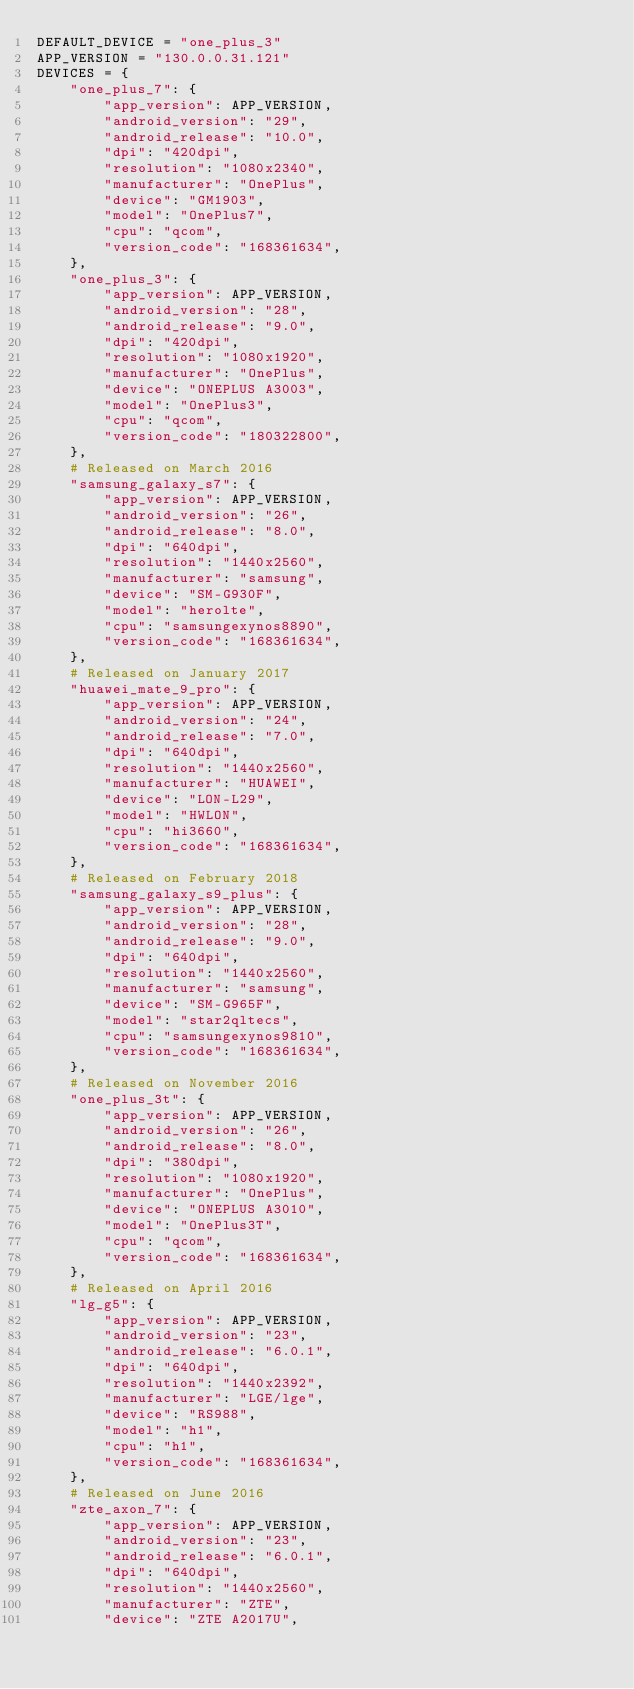Convert code to text. <code><loc_0><loc_0><loc_500><loc_500><_Python_>DEFAULT_DEVICE = "one_plus_3"
APP_VERSION = "130.0.0.31.121"
DEVICES = {
    "one_plus_7": {
        "app_version": APP_VERSION,
        "android_version": "29",
        "android_release": "10.0",
        "dpi": "420dpi",
        "resolution": "1080x2340",
        "manufacturer": "OnePlus",
        "device": "GM1903",
        "model": "OnePlus7",
        "cpu": "qcom",
        "version_code": "168361634",
    },
    "one_plus_3": {
        "app_version": APP_VERSION,
        "android_version": "28",
        "android_release": "9.0",
        "dpi": "420dpi",
        "resolution": "1080x1920",
        "manufacturer": "OnePlus",
        "device": "ONEPLUS A3003",
        "model": "OnePlus3",
        "cpu": "qcom",
        "version_code": "180322800",
    },
    # Released on March 2016
    "samsung_galaxy_s7": {
        "app_version": APP_VERSION,
        "android_version": "26",
        "android_release": "8.0",
        "dpi": "640dpi",
        "resolution": "1440x2560",
        "manufacturer": "samsung",
        "device": "SM-G930F",
        "model": "herolte",
        "cpu": "samsungexynos8890",
        "version_code": "168361634",
    },
    # Released on January 2017
    "huawei_mate_9_pro": {
        "app_version": APP_VERSION,
        "android_version": "24",
        "android_release": "7.0",
        "dpi": "640dpi",
        "resolution": "1440x2560",
        "manufacturer": "HUAWEI",
        "device": "LON-L29",
        "model": "HWLON",
        "cpu": "hi3660",
        "version_code": "168361634",
    },
    # Released on February 2018
    "samsung_galaxy_s9_plus": {
        "app_version": APP_VERSION,
        "android_version": "28",
        "android_release": "9.0",
        "dpi": "640dpi",
        "resolution": "1440x2560",
        "manufacturer": "samsung",
        "device": "SM-G965F",
        "model": "star2qltecs",
        "cpu": "samsungexynos9810",
        "version_code": "168361634",
    },
    # Released on November 2016
    "one_plus_3t": {
        "app_version": APP_VERSION,
        "android_version": "26",
        "android_release": "8.0",
        "dpi": "380dpi",
        "resolution": "1080x1920",
        "manufacturer": "OnePlus",
        "device": "ONEPLUS A3010",
        "model": "OnePlus3T",
        "cpu": "qcom",
        "version_code": "168361634",
    },
    # Released on April 2016
    "lg_g5": {
        "app_version": APP_VERSION,
        "android_version": "23",
        "android_release": "6.0.1",
        "dpi": "640dpi",
        "resolution": "1440x2392",
        "manufacturer": "LGE/lge",
        "device": "RS988",
        "model": "h1",
        "cpu": "h1",
        "version_code": "168361634",
    },
    # Released on June 2016
    "zte_axon_7": {
        "app_version": APP_VERSION,
        "android_version": "23",
        "android_release": "6.0.1",
        "dpi": "640dpi",
        "resolution": "1440x2560",
        "manufacturer": "ZTE",
        "device": "ZTE A2017U",</code> 